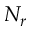Convert formula to latex. <formula><loc_0><loc_0><loc_500><loc_500>N _ { r }</formula> 